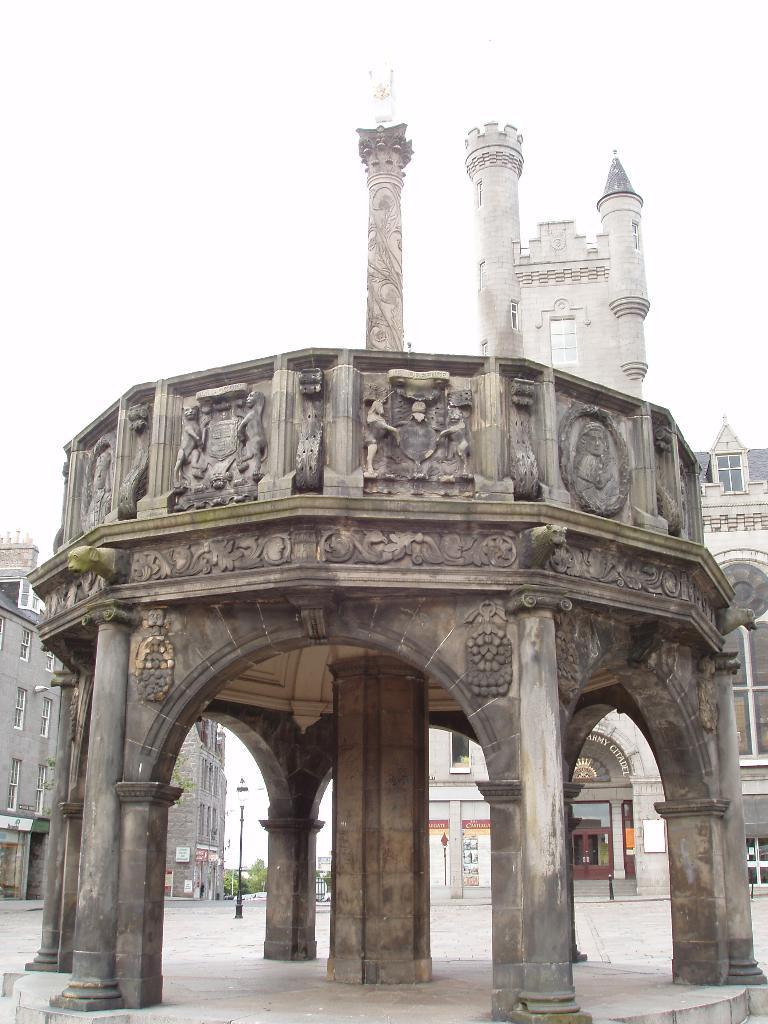What architectural features can be seen in the image? There are pillars in the image. What type of decorations are on the wall in the image? There are statues on the wall in the image. What can be seen in the distance in the image? There are buildings, a light on a pole, boards, trees, and the sky visible in the background of the image. What type of lead can be seen in the image? There is no lead present in the image. How does the caretaker maintain the statues in the image? There is no caretaker or maintenance activity depicted in the image. 